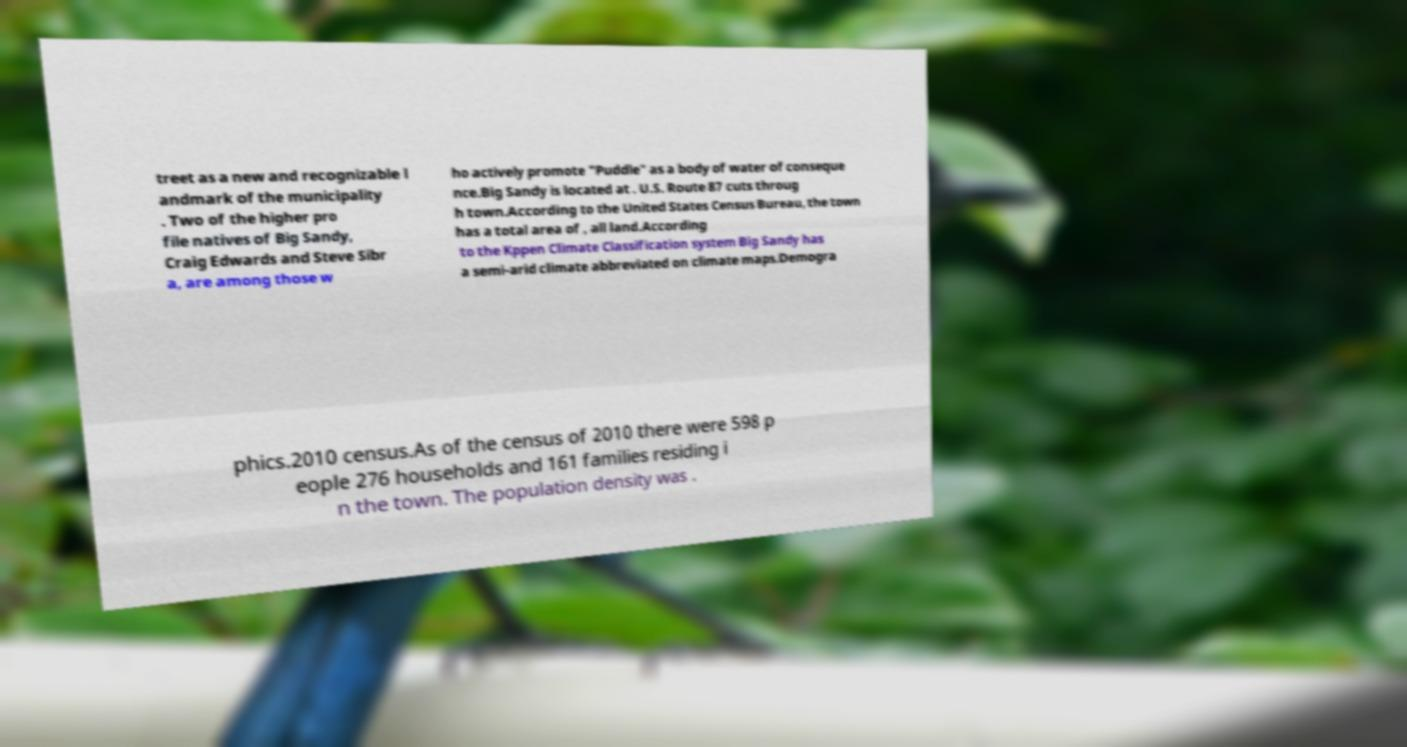I need the written content from this picture converted into text. Can you do that? treet as a new and recognizable l andmark of the municipality . Two of the higher pro file natives of Big Sandy, Craig Edwards and Steve Sibr a, are among those w ho actively promote "Puddle" as a body of water of conseque nce.Big Sandy is located at . U.S. Route 87 cuts throug h town.According to the United States Census Bureau, the town has a total area of , all land.According to the Kppen Climate Classification system Big Sandy has a semi-arid climate abbreviated on climate maps.Demogra phics.2010 census.As of the census of 2010 there were 598 p eople 276 households and 161 families residing i n the town. The population density was . 